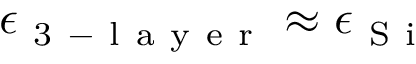<formula> <loc_0><loc_0><loc_500><loc_500>\epsilon _ { 3 - l a y e r } \approx \epsilon _ { S i }</formula> 